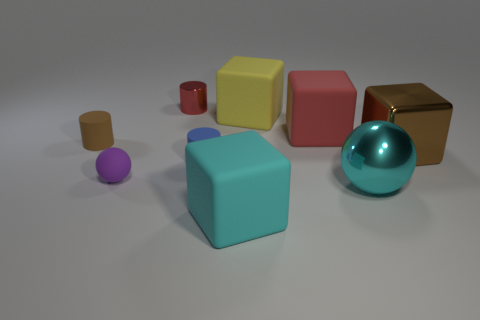Subtract all cyan rubber blocks. How many blocks are left? 3 Subtract all spheres. How many objects are left? 7 Subtract 1 blocks. How many blocks are left? 3 Add 8 big metal balls. How many big metal balls are left? 9 Add 4 big shiny things. How many big shiny things exist? 6 Subtract all cyan balls. How many balls are left? 1 Subtract 0 green spheres. How many objects are left? 9 Subtract all brown cylinders. Subtract all yellow blocks. How many cylinders are left? 2 Subtract all blue cubes. How many cyan spheres are left? 1 Subtract all small purple spheres. Subtract all cyan objects. How many objects are left? 6 